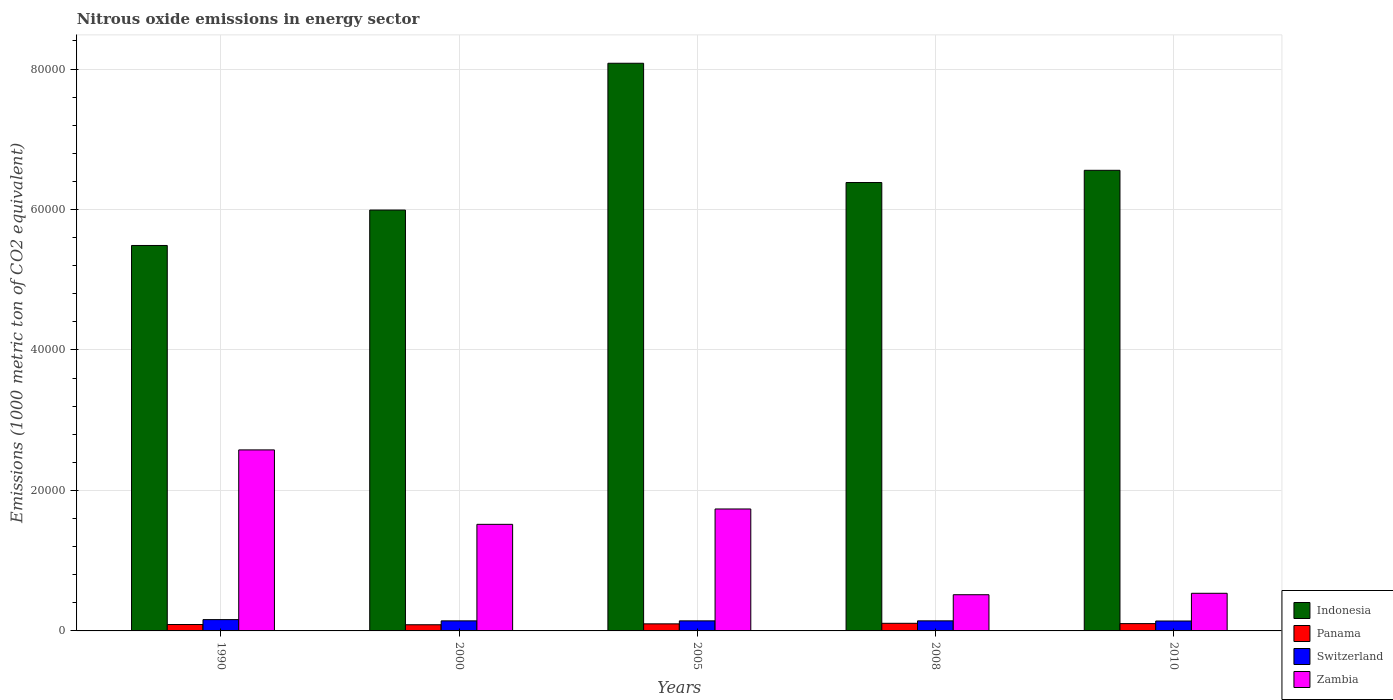Are the number of bars on each tick of the X-axis equal?
Your answer should be very brief. Yes. How many bars are there on the 5th tick from the right?
Your answer should be compact. 4. What is the label of the 3rd group of bars from the left?
Offer a terse response. 2005. In how many cases, is the number of bars for a given year not equal to the number of legend labels?
Give a very brief answer. 0. What is the amount of nitrous oxide emitted in Zambia in 2005?
Ensure brevity in your answer.  1.74e+04. Across all years, what is the maximum amount of nitrous oxide emitted in Panama?
Your answer should be compact. 1084.9. Across all years, what is the minimum amount of nitrous oxide emitted in Panama?
Offer a terse response. 878.4. In which year was the amount of nitrous oxide emitted in Zambia maximum?
Offer a very short reply. 1990. In which year was the amount of nitrous oxide emitted in Zambia minimum?
Make the answer very short. 2008. What is the total amount of nitrous oxide emitted in Indonesia in the graph?
Provide a succinct answer. 3.25e+05. What is the difference between the amount of nitrous oxide emitted in Panama in 1990 and that in 2008?
Ensure brevity in your answer.  -174.5. What is the difference between the amount of nitrous oxide emitted in Switzerland in 2000 and the amount of nitrous oxide emitted in Indonesia in 1990?
Keep it short and to the point. -5.34e+04. What is the average amount of nitrous oxide emitted in Indonesia per year?
Provide a short and direct response. 6.50e+04. In the year 2005, what is the difference between the amount of nitrous oxide emitted in Switzerland and amount of nitrous oxide emitted in Zambia?
Ensure brevity in your answer.  -1.59e+04. What is the ratio of the amount of nitrous oxide emitted in Indonesia in 1990 to that in 2000?
Make the answer very short. 0.92. Is the amount of nitrous oxide emitted in Indonesia in 1990 less than that in 2008?
Your response must be concise. Yes. Is the difference between the amount of nitrous oxide emitted in Switzerland in 2005 and 2010 greater than the difference between the amount of nitrous oxide emitted in Zambia in 2005 and 2010?
Your answer should be compact. No. What is the difference between the highest and the second highest amount of nitrous oxide emitted in Zambia?
Your answer should be compact. 8411.4. What is the difference between the highest and the lowest amount of nitrous oxide emitted in Indonesia?
Give a very brief answer. 2.59e+04. Is the sum of the amount of nitrous oxide emitted in Zambia in 2008 and 2010 greater than the maximum amount of nitrous oxide emitted in Panama across all years?
Your answer should be very brief. Yes. What does the 1st bar from the left in 2005 represents?
Your response must be concise. Indonesia. Are all the bars in the graph horizontal?
Your response must be concise. No. What is the difference between two consecutive major ticks on the Y-axis?
Ensure brevity in your answer.  2.00e+04. Are the values on the major ticks of Y-axis written in scientific E-notation?
Give a very brief answer. No. Does the graph contain any zero values?
Provide a short and direct response. No. Does the graph contain grids?
Offer a terse response. Yes. Where does the legend appear in the graph?
Give a very brief answer. Bottom right. How are the legend labels stacked?
Your answer should be compact. Vertical. What is the title of the graph?
Your response must be concise. Nitrous oxide emissions in energy sector. Does "Samoa" appear as one of the legend labels in the graph?
Provide a short and direct response. No. What is the label or title of the Y-axis?
Provide a succinct answer. Emissions (1000 metric ton of CO2 equivalent). What is the Emissions (1000 metric ton of CO2 equivalent) in Indonesia in 1990?
Offer a terse response. 5.49e+04. What is the Emissions (1000 metric ton of CO2 equivalent) in Panama in 1990?
Your answer should be very brief. 910.4. What is the Emissions (1000 metric ton of CO2 equivalent) in Switzerland in 1990?
Give a very brief answer. 1610.2. What is the Emissions (1000 metric ton of CO2 equivalent) of Zambia in 1990?
Keep it short and to the point. 2.58e+04. What is the Emissions (1000 metric ton of CO2 equivalent) in Indonesia in 2000?
Keep it short and to the point. 5.99e+04. What is the Emissions (1000 metric ton of CO2 equivalent) of Panama in 2000?
Provide a succinct answer. 878.4. What is the Emissions (1000 metric ton of CO2 equivalent) of Switzerland in 2000?
Offer a very short reply. 1432.5. What is the Emissions (1000 metric ton of CO2 equivalent) in Zambia in 2000?
Make the answer very short. 1.52e+04. What is the Emissions (1000 metric ton of CO2 equivalent) of Indonesia in 2005?
Your answer should be compact. 8.08e+04. What is the Emissions (1000 metric ton of CO2 equivalent) in Panama in 2005?
Provide a short and direct response. 1006.8. What is the Emissions (1000 metric ton of CO2 equivalent) in Switzerland in 2005?
Ensure brevity in your answer.  1431.1. What is the Emissions (1000 metric ton of CO2 equivalent) of Zambia in 2005?
Your answer should be compact. 1.74e+04. What is the Emissions (1000 metric ton of CO2 equivalent) in Indonesia in 2008?
Provide a succinct answer. 6.38e+04. What is the Emissions (1000 metric ton of CO2 equivalent) of Panama in 2008?
Provide a succinct answer. 1084.9. What is the Emissions (1000 metric ton of CO2 equivalent) in Switzerland in 2008?
Your answer should be compact. 1433. What is the Emissions (1000 metric ton of CO2 equivalent) of Zambia in 2008?
Make the answer very short. 5152.9. What is the Emissions (1000 metric ton of CO2 equivalent) in Indonesia in 2010?
Provide a succinct answer. 6.56e+04. What is the Emissions (1000 metric ton of CO2 equivalent) of Panama in 2010?
Offer a very short reply. 1040.4. What is the Emissions (1000 metric ton of CO2 equivalent) in Switzerland in 2010?
Ensure brevity in your answer.  1411.6. What is the Emissions (1000 metric ton of CO2 equivalent) in Zambia in 2010?
Keep it short and to the point. 5357.6. Across all years, what is the maximum Emissions (1000 metric ton of CO2 equivalent) in Indonesia?
Make the answer very short. 8.08e+04. Across all years, what is the maximum Emissions (1000 metric ton of CO2 equivalent) of Panama?
Provide a short and direct response. 1084.9. Across all years, what is the maximum Emissions (1000 metric ton of CO2 equivalent) of Switzerland?
Provide a succinct answer. 1610.2. Across all years, what is the maximum Emissions (1000 metric ton of CO2 equivalent) of Zambia?
Make the answer very short. 2.58e+04. Across all years, what is the minimum Emissions (1000 metric ton of CO2 equivalent) of Indonesia?
Give a very brief answer. 5.49e+04. Across all years, what is the minimum Emissions (1000 metric ton of CO2 equivalent) of Panama?
Offer a very short reply. 878.4. Across all years, what is the minimum Emissions (1000 metric ton of CO2 equivalent) of Switzerland?
Provide a succinct answer. 1411.6. Across all years, what is the minimum Emissions (1000 metric ton of CO2 equivalent) of Zambia?
Give a very brief answer. 5152.9. What is the total Emissions (1000 metric ton of CO2 equivalent) of Indonesia in the graph?
Your answer should be very brief. 3.25e+05. What is the total Emissions (1000 metric ton of CO2 equivalent) in Panama in the graph?
Your response must be concise. 4920.9. What is the total Emissions (1000 metric ton of CO2 equivalent) of Switzerland in the graph?
Give a very brief answer. 7318.4. What is the total Emissions (1000 metric ton of CO2 equivalent) of Zambia in the graph?
Make the answer very short. 6.88e+04. What is the difference between the Emissions (1000 metric ton of CO2 equivalent) of Indonesia in 1990 and that in 2000?
Offer a terse response. -5044.7. What is the difference between the Emissions (1000 metric ton of CO2 equivalent) of Panama in 1990 and that in 2000?
Keep it short and to the point. 32. What is the difference between the Emissions (1000 metric ton of CO2 equivalent) of Switzerland in 1990 and that in 2000?
Provide a succinct answer. 177.7. What is the difference between the Emissions (1000 metric ton of CO2 equivalent) in Zambia in 1990 and that in 2000?
Give a very brief answer. 1.06e+04. What is the difference between the Emissions (1000 metric ton of CO2 equivalent) of Indonesia in 1990 and that in 2005?
Ensure brevity in your answer.  -2.59e+04. What is the difference between the Emissions (1000 metric ton of CO2 equivalent) of Panama in 1990 and that in 2005?
Provide a short and direct response. -96.4. What is the difference between the Emissions (1000 metric ton of CO2 equivalent) in Switzerland in 1990 and that in 2005?
Offer a very short reply. 179.1. What is the difference between the Emissions (1000 metric ton of CO2 equivalent) of Zambia in 1990 and that in 2005?
Your answer should be very brief. 8411.4. What is the difference between the Emissions (1000 metric ton of CO2 equivalent) of Indonesia in 1990 and that in 2008?
Provide a succinct answer. -8962.8. What is the difference between the Emissions (1000 metric ton of CO2 equivalent) of Panama in 1990 and that in 2008?
Offer a terse response. -174.5. What is the difference between the Emissions (1000 metric ton of CO2 equivalent) in Switzerland in 1990 and that in 2008?
Ensure brevity in your answer.  177.2. What is the difference between the Emissions (1000 metric ton of CO2 equivalent) in Zambia in 1990 and that in 2008?
Your response must be concise. 2.06e+04. What is the difference between the Emissions (1000 metric ton of CO2 equivalent) in Indonesia in 1990 and that in 2010?
Your answer should be compact. -1.07e+04. What is the difference between the Emissions (1000 metric ton of CO2 equivalent) in Panama in 1990 and that in 2010?
Provide a short and direct response. -130. What is the difference between the Emissions (1000 metric ton of CO2 equivalent) in Switzerland in 1990 and that in 2010?
Give a very brief answer. 198.6. What is the difference between the Emissions (1000 metric ton of CO2 equivalent) in Zambia in 1990 and that in 2010?
Provide a succinct answer. 2.04e+04. What is the difference between the Emissions (1000 metric ton of CO2 equivalent) in Indonesia in 2000 and that in 2005?
Your answer should be very brief. -2.09e+04. What is the difference between the Emissions (1000 metric ton of CO2 equivalent) in Panama in 2000 and that in 2005?
Make the answer very short. -128.4. What is the difference between the Emissions (1000 metric ton of CO2 equivalent) of Zambia in 2000 and that in 2005?
Provide a short and direct response. -2187.2. What is the difference between the Emissions (1000 metric ton of CO2 equivalent) of Indonesia in 2000 and that in 2008?
Your answer should be compact. -3918.1. What is the difference between the Emissions (1000 metric ton of CO2 equivalent) in Panama in 2000 and that in 2008?
Offer a very short reply. -206.5. What is the difference between the Emissions (1000 metric ton of CO2 equivalent) in Zambia in 2000 and that in 2008?
Your answer should be very brief. 1.00e+04. What is the difference between the Emissions (1000 metric ton of CO2 equivalent) in Indonesia in 2000 and that in 2010?
Give a very brief answer. -5659.3. What is the difference between the Emissions (1000 metric ton of CO2 equivalent) in Panama in 2000 and that in 2010?
Your response must be concise. -162. What is the difference between the Emissions (1000 metric ton of CO2 equivalent) of Switzerland in 2000 and that in 2010?
Your response must be concise. 20.9. What is the difference between the Emissions (1000 metric ton of CO2 equivalent) in Zambia in 2000 and that in 2010?
Make the answer very short. 9818.5. What is the difference between the Emissions (1000 metric ton of CO2 equivalent) of Indonesia in 2005 and that in 2008?
Ensure brevity in your answer.  1.70e+04. What is the difference between the Emissions (1000 metric ton of CO2 equivalent) in Panama in 2005 and that in 2008?
Provide a succinct answer. -78.1. What is the difference between the Emissions (1000 metric ton of CO2 equivalent) of Zambia in 2005 and that in 2008?
Offer a very short reply. 1.22e+04. What is the difference between the Emissions (1000 metric ton of CO2 equivalent) of Indonesia in 2005 and that in 2010?
Offer a very short reply. 1.52e+04. What is the difference between the Emissions (1000 metric ton of CO2 equivalent) in Panama in 2005 and that in 2010?
Provide a succinct answer. -33.6. What is the difference between the Emissions (1000 metric ton of CO2 equivalent) of Zambia in 2005 and that in 2010?
Offer a very short reply. 1.20e+04. What is the difference between the Emissions (1000 metric ton of CO2 equivalent) in Indonesia in 2008 and that in 2010?
Offer a terse response. -1741.2. What is the difference between the Emissions (1000 metric ton of CO2 equivalent) in Panama in 2008 and that in 2010?
Offer a terse response. 44.5. What is the difference between the Emissions (1000 metric ton of CO2 equivalent) in Switzerland in 2008 and that in 2010?
Give a very brief answer. 21.4. What is the difference between the Emissions (1000 metric ton of CO2 equivalent) of Zambia in 2008 and that in 2010?
Your response must be concise. -204.7. What is the difference between the Emissions (1000 metric ton of CO2 equivalent) of Indonesia in 1990 and the Emissions (1000 metric ton of CO2 equivalent) of Panama in 2000?
Ensure brevity in your answer.  5.40e+04. What is the difference between the Emissions (1000 metric ton of CO2 equivalent) of Indonesia in 1990 and the Emissions (1000 metric ton of CO2 equivalent) of Switzerland in 2000?
Ensure brevity in your answer.  5.34e+04. What is the difference between the Emissions (1000 metric ton of CO2 equivalent) of Indonesia in 1990 and the Emissions (1000 metric ton of CO2 equivalent) of Zambia in 2000?
Your answer should be compact. 3.97e+04. What is the difference between the Emissions (1000 metric ton of CO2 equivalent) of Panama in 1990 and the Emissions (1000 metric ton of CO2 equivalent) of Switzerland in 2000?
Your response must be concise. -522.1. What is the difference between the Emissions (1000 metric ton of CO2 equivalent) of Panama in 1990 and the Emissions (1000 metric ton of CO2 equivalent) of Zambia in 2000?
Offer a terse response. -1.43e+04. What is the difference between the Emissions (1000 metric ton of CO2 equivalent) in Switzerland in 1990 and the Emissions (1000 metric ton of CO2 equivalent) in Zambia in 2000?
Your answer should be very brief. -1.36e+04. What is the difference between the Emissions (1000 metric ton of CO2 equivalent) in Indonesia in 1990 and the Emissions (1000 metric ton of CO2 equivalent) in Panama in 2005?
Keep it short and to the point. 5.39e+04. What is the difference between the Emissions (1000 metric ton of CO2 equivalent) in Indonesia in 1990 and the Emissions (1000 metric ton of CO2 equivalent) in Switzerland in 2005?
Ensure brevity in your answer.  5.35e+04. What is the difference between the Emissions (1000 metric ton of CO2 equivalent) of Indonesia in 1990 and the Emissions (1000 metric ton of CO2 equivalent) of Zambia in 2005?
Your answer should be very brief. 3.75e+04. What is the difference between the Emissions (1000 metric ton of CO2 equivalent) in Panama in 1990 and the Emissions (1000 metric ton of CO2 equivalent) in Switzerland in 2005?
Provide a succinct answer. -520.7. What is the difference between the Emissions (1000 metric ton of CO2 equivalent) of Panama in 1990 and the Emissions (1000 metric ton of CO2 equivalent) of Zambia in 2005?
Give a very brief answer. -1.65e+04. What is the difference between the Emissions (1000 metric ton of CO2 equivalent) in Switzerland in 1990 and the Emissions (1000 metric ton of CO2 equivalent) in Zambia in 2005?
Your response must be concise. -1.58e+04. What is the difference between the Emissions (1000 metric ton of CO2 equivalent) of Indonesia in 1990 and the Emissions (1000 metric ton of CO2 equivalent) of Panama in 2008?
Give a very brief answer. 5.38e+04. What is the difference between the Emissions (1000 metric ton of CO2 equivalent) in Indonesia in 1990 and the Emissions (1000 metric ton of CO2 equivalent) in Switzerland in 2008?
Ensure brevity in your answer.  5.34e+04. What is the difference between the Emissions (1000 metric ton of CO2 equivalent) in Indonesia in 1990 and the Emissions (1000 metric ton of CO2 equivalent) in Zambia in 2008?
Offer a terse response. 4.97e+04. What is the difference between the Emissions (1000 metric ton of CO2 equivalent) of Panama in 1990 and the Emissions (1000 metric ton of CO2 equivalent) of Switzerland in 2008?
Provide a short and direct response. -522.6. What is the difference between the Emissions (1000 metric ton of CO2 equivalent) in Panama in 1990 and the Emissions (1000 metric ton of CO2 equivalent) in Zambia in 2008?
Make the answer very short. -4242.5. What is the difference between the Emissions (1000 metric ton of CO2 equivalent) in Switzerland in 1990 and the Emissions (1000 metric ton of CO2 equivalent) in Zambia in 2008?
Offer a very short reply. -3542.7. What is the difference between the Emissions (1000 metric ton of CO2 equivalent) in Indonesia in 1990 and the Emissions (1000 metric ton of CO2 equivalent) in Panama in 2010?
Keep it short and to the point. 5.38e+04. What is the difference between the Emissions (1000 metric ton of CO2 equivalent) in Indonesia in 1990 and the Emissions (1000 metric ton of CO2 equivalent) in Switzerland in 2010?
Ensure brevity in your answer.  5.35e+04. What is the difference between the Emissions (1000 metric ton of CO2 equivalent) of Indonesia in 1990 and the Emissions (1000 metric ton of CO2 equivalent) of Zambia in 2010?
Offer a very short reply. 4.95e+04. What is the difference between the Emissions (1000 metric ton of CO2 equivalent) of Panama in 1990 and the Emissions (1000 metric ton of CO2 equivalent) of Switzerland in 2010?
Your answer should be compact. -501.2. What is the difference between the Emissions (1000 metric ton of CO2 equivalent) of Panama in 1990 and the Emissions (1000 metric ton of CO2 equivalent) of Zambia in 2010?
Offer a very short reply. -4447.2. What is the difference between the Emissions (1000 metric ton of CO2 equivalent) in Switzerland in 1990 and the Emissions (1000 metric ton of CO2 equivalent) in Zambia in 2010?
Your response must be concise. -3747.4. What is the difference between the Emissions (1000 metric ton of CO2 equivalent) of Indonesia in 2000 and the Emissions (1000 metric ton of CO2 equivalent) of Panama in 2005?
Ensure brevity in your answer.  5.89e+04. What is the difference between the Emissions (1000 metric ton of CO2 equivalent) of Indonesia in 2000 and the Emissions (1000 metric ton of CO2 equivalent) of Switzerland in 2005?
Give a very brief answer. 5.85e+04. What is the difference between the Emissions (1000 metric ton of CO2 equivalent) of Indonesia in 2000 and the Emissions (1000 metric ton of CO2 equivalent) of Zambia in 2005?
Your response must be concise. 4.26e+04. What is the difference between the Emissions (1000 metric ton of CO2 equivalent) in Panama in 2000 and the Emissions (1000 metric ton of CO2 equivalent) in Switzerland in 2005?
Offer a terse response. -552.7. What is the difference between the Emissions (1000 metric ton of CO2 equivalent) of Panama in 2000 and the Emissions (1000 metric ton of CO2 equivalent) of Zambia in 2005?
Your answer should be compact. -1.65e+04. What is the difference between the Emissions (1000 metric ton of CO2 equivalent) of Switzerland in 2000 and the Emissions (1000 metric ton of CO2 equivalent) of Zambia in 2005?
Provide a short and direct response. -1.59e+04. What is the difference between the Emissions (1000 metric ton of CO2 equivalent) in Indonesia in 2000 and the Emissions (1000 metric ton of CO2 equivalent) in Panama in 2008?
Keep it short and to the point. 5.88e+04. What is the difference between the Emissions (1000 metric ton of CO2 equivalent) in Indonesia in 2000 and the Emissions (1000 metric ton of CO2 equivalent) in Switzerland in 2008?
Keep it short and to the point. 5.85e+04. What is the difference between the Emissions (1000 metric ton of CO2 equivalent) in Indonesia in 2000 and the Emissions (1000 metric ton of CO2 equivalent) in Zambia in 2008?
Offer a very short reply. 5.48e+04. What is the difference between the Emissions (1000 metric ton of CO2 equivalent) in Panama in 2000 and the Emissions (1000 metric ton of CO2 equivalent) in Switzerland in 2008?
Ensure brevity in your answer.  -554.6. What is the difference between the Emissions (1000 metric ton of CO2 equivalent) of Panama in 2000 and the Emissions (1000 metric ton of CO2 equivalent) of Zambia in 2008?
Your answer should be compact. -4274.5. What is the difference between the Emissions (1000 metric ton of CO2 equivalent) in Switzerland in 2000 and the Emissions (1000 metric ton of CO2 equivalent) in Zambia in 2008?
Your answer should be very brief. -3720.4. What is the difference between the Emissions (1000 metric ton of CO2 equivalent) in Indonesia in 2000 and the Emissions (1000 metric ton of CO2 equivalent) in Panama in 2010?
Offer a very short reply. 5.89e+04. What is the difference between the Emissions (1000 metric ton of CO2 equivalent) of Indonesia in 2000 and the Emissions (1000 metric ton of CO2 equivalent) of Switzerland in 2010?
Your response must be concise. 5.85e+04. What is the difference between the Emissions (1000 metric ton of CO2 equivalent) of Indonesia in 2000 and the Emissions (1000 metric ton of CO2 equivalent) of Zambia in 2010?
Offer a terse response. 5.46e+04. What is the difference between the Emissions (1000 metric ton of CO2 equivalent) in Panama in 2000 and the Emissions (1000 metric ton of CO2 equivalent) in Switzerland in 2010?
Your response must be concise. -533.2. What is the difference between the Emissions (1000 metric ton of CO2 equivalent) of Panama in 2000 and the Emissions (1000 metric ton of CO2 equivalent) of Zambia in 2010?
Keep it short and to the point. -4479.2. What is the difference between the Emissions (1000 metric ton of CO2 equivalent) in Switzerland in 2000 and the Emissions (1000 metric ton of CO2 equivalent) in Zambia in 2010?
Keep it short and to the point. -3925.1. What is the difference between the Emissions (1000 metric ton of CO2 equivalent) of Indonesia in 2005 and the Emissions (1000 metric ton of CO2 equivalent) of Panama in 2008?
Provide a short and direct response. 7.97e+04. What is the difference between the Emissions (1000 metric ton of CO2 equivalent) in Indonesia in 2005 and the Emissions (1000 metric ton of CO2 equivalent) in Switzerland in 2008?
Your answer should be compact. 7.94e+04. What is the difference between the Emissions (1000 metric ton of CO2 equivalent) in Indonesia in 2005 and the Emissions (1000 metric ton of CO2 equivalent) in Zambia in 2008?
Provide a short and direct response. 7.57e+04. What is the difference between the Emissions (1000 metric ton of CO2 equivalent) in Panama in 2005 and the Emissions (1000 metric ton of CO2 equivalent) in Switzerland in 2008?
Make the answer very short. -426.2. What is the difference between the Emissions (1000 metric ton of CO2 equivalent) in Panama in 2005 and the Emissions (1000 metric ton of CO2 equivalent) in Zambia in 2008?
Make the answer very short. -4146.1. What is the difference between the Emissions (1000 metric ton of CO2 equivalent) in Switzerland in 2005 and the Emissions (1000 metric ton of CO2 equivalent) in Zambia in 2008?
Give a very brief answer. -3721.8. What is the difference between the Emissions (1000 metric ton of CO2 equivalent) of Indonesia in 2005 and the Emissions (1000 metric ton of CO2 equivalent) of Panama in 2010?
Your answer should be very brief. 7.98e+04. What is the difference between the Emissions (1000 metric ton of CO2 equivalent) of Indonesia in 2005 and the Emissions (1000 metric ton of CO2 equivalent) of Switzerland in 2010?
Provide a succinct answer. 7.94e+04. What is the difference between the Emissions (1000 metric ton of CO2 equivalent) in Indonesia in 2005 and the Emissions (1000 metric ton of CO2 equivalent) in Zambia in 2010?
Your answer should be compact. 7.55e+04. What is the difference between the Emissions (1000 metric ton of CO2 equivalent) of Panama in 2005 and the Emissions (1000 metric ton of CO2 equivalent) of Switzerland in 2010?
Provide a short and direct response. -404.8. What is the difference between the Emissions (1000 metric ton of CO2 equivalent) of Panama in 2005 and the Emissions (1000 metric ton of CO2 equivalent) of Zambia in 2010?
Your answer should be very brief. -4350.8. What is the difference between the Emissions (1000 metric ton of CO2 equivalent) in Switzerland in 2005 and the Emissions (1000 metric ton of CO2 equivalent) in Zambia in 2010?
Your answer should be very brief. -3926.5. What is the difference between the Emissions (1000 metric ton of CO2 equivalent) in Indonesia in 2008 and the Emissions (1000 metric ton of CO2 equivalent) in Panama in 2010?
Your answer should be very brief. 6.28e+04. What is the difference between the Emissions (1000 metric ton of CO2 equivalent) of Indonesia in 2008 and the Emissions (1000 metric ton of CO2 equivalent) of Switzerland in 2010?
Make the answer very short. 6.24e+04. What is the difference between the Emissions (1000 metric ton of CO2 equivalent) in Indonesia in 2008 and the Emissions (1000 metric ton of CO2 equivalent) in Zambia in 2010?
Offer a very short reply. 5.85e+04. What is the difference between the Emissions (1000 metric ton of CO2 equivalent) in Panama in 2008 and the Emissions (1000 metric ton of CO2 equivalent) in Switzerland in 2010?
Offer a very short reply. -326.7. What is the difference between the Emissions (1000 metric ton of CO2 equivalent) of Panama in 2008 and the Emissions (1000 metric ton of CO2 equivalent) of Zambia in 2010?
Offer a very short reply. -4272.7. What is the difference between the Emissions (1000 metric ton of CO2 equivalent) of Switzerland in 2008 and the Emissions (1000 metric ton of CO2 equivalent) of Zambia in 2010?
Your answer should be compact. -3924.6. What is the average Emissions (1000 metric ton of CO2 equivalent) in Indonesia per year?
Give a very brief answer. 6.50e+04. What is the average Emissions (1000 metric ton of CO2 equivalent) of Panama per year?
Make the answer very short. 984.18. What is the average Emissions (1000 metric ton of CO2 equivalent) of Switzerland per year?
Offer a very short reply. 1463.68. What is the average Emissions (1000 metric ton of CO2 equivalent) of Zambia per year?
Your response must be concise. 1.38e+04. In the year 1990, what is the difference between the Emissions (1000 metric ton of CO2 equivalent) of Indonesia and Emissions (1000 metric ton of CO2 equivalent) of Panama?
Keep it short and to the point. 5.40e+04. In the year 1990, what is the difference between the Emissions (1000 metric ton of CO2 equivalent) of Indonesia and Emissions (1000 metric ton of CO2 equivalent) of Switzerland?
Provide a short and direct response. 5.33e+04. In the year 1990, what is the difference between the Emissions (1000 metric ton of CO2 equivalent) of Indonesia and Emissions (1000 metric ton of CO2 equivalent) of Zambia?
Your answer should be very brief. 2.91e+04. In the year 1990, what is the difference between the Emissions (1000 metric ton of CO2 equivalent) of Panama and Emissions (1000 metric ton of CO2 equivalent) of Switzerland?
Offer a very short reply. -699.8. In the year 1990, what is the difference between the Emissions (1000 metric ton of CO2 equivalent) in Panama and Emissions (1000 metric ton of CO2 equivalent) in Zambia?
Give a very brief answer. -2.49e+04. In the year 1990, what is the difference between the Emissions (1000 metric ton of CO2 equivalent) of Switzerland and Emissions (1000 metric ton of CO2 equivalent) of Zambia?
Offer a very short reply. -2.42e+04. In the year 2000, what is the difference between the Emissions (1000 metric ton of CO2 equivalent) of Indonesia and Emissions (1000 metric ton of CO2 equivalent) of Panama?
Keep it short and to the point. 5.90e+04. In the year 2000, what is the difference between the Emissions (1000 metric ton of CO2 equivalent) of Indonesia and Emissions (1000 metric ton of CO2 equivalent) of Switzerland?
Ensure brevity in your answer.  5.85e+04. In the year 2000, what is the difference between the Emissions (1000 metric ton of CO2 equivalent) of Indonesia and Emissions (1000 metric ton of CO2 equivalent) of Zambia?
Your response must be concise. 4.47e+04. In the year 2000, what is the difference between the Emissions (1000 metric ton of CO2 equivalent) of Panama and Emissions (1000 metric ton of CO2 equivalent) of Switzerland?
Your answer should be compact. -554.1. In the year 2000, what is the difference between the Emissions (1000 metric ton of CO2 equivalent) of Panama and Emissions (1000 metric ton of CO2 equivalent) of Zambia?
Give a very brief answer. -1.43e+04. In the year 2000, what is the difference between the Emissions (1000 metric ton of CO2 equivalent) of Switzerland and Emissions (1000 metric ton of CO2 equivalent) of Zambia?
Give a very brief answer. -1.37e+04. In the year 2005, what is the difference between the Emissions (1000 metric ton of CO2 equivalent) of Indonesia and Emissions (1000 metric ton of CO2 equivalent) of Panama?
Offer a terse response. 7.98e+04. In the year 2005, what is the difference between the Emissions (1000 metric ton of CO2 equivalent) of Indonesia and Emissions (1000 metric ton of CO2 equivalent) of Switzerland?
Make the answer very short. 7.94e+04. In the year 2005, what is the difference between the Emissions (1000 metric ton of CO2 equivalent) in Indonesia and Emissions (1000 metric ton of CO2 equivalent) in Zambia?
Make the answer very short. 6.35e+04. In the year 2005, what is the difference between the Emissions (1000 metric ton of CO2 equivalent) in Panama and Emissions (1000 metric ton of CO2 equivalent) in Switzerland?
Provide a short and direct response. -424.3. In the year 2005, what is the difference between the Emissions (1000 metric ton of CO2 equivalent) in Panama and Emissions (1000 metric ton of CO2 equivalent) in Zambia?
Your response must be concise. -1.64e+04. In the year 2005, what is the difference between the Emissions (1000 metric ton of CO2 equivalent) of Switzerland and Emissions (1000 metric ton of CO2 equivalent) of Zambia?
Provide a succinct answer. -1.59e+04. In the year 2008, what is the difference between the Emissions (1000 metric ton of CO2 equivalent) of Indonesia and Emissions (1000 metric ton of CO2 equivalent) of Panama?
Provide a succinct answer. 6.28e+04. In the year 2008, what is the difference between the Emissions (1000 metric ton of CO2 equivalent) of Indonesia and Emissions (1000 metric ton of CO2 equivalent) of Switzerland?
Your answer should be very brief. 6.24e+04. In the year 2008, what is the difference between the Emissions (1000 metric ton of CO2 equivalent) of Indonesia and Emissions (1000 metric ton of CO2 equivalent) of Zambia?
Your response must be concise. 5.87e+04. In the year 2008, what is the difference between the Emissions (1000 metric ton of CO2 equivalent) of Panama and Emissions (1000 metric ton of CO2 equivalent) of Switzerland?
Your answer should be very brief. -348.1. In the year 2008, what is the difference between the Emissions (1000 metric ton of CO2 equivalent) of Panama and Emissions (1000 metric ton of CO2 equivalent) of Zambia?
Make the answer very short. -4068. In the year 2008, what is the difference between the Emissions (1000 metric ton of CO2 equivalent) in Switzerland and Emissions (1000 metric ton of CO2 equivalent) in Zambia?
Ensure brevity in your answer.  -3719.9. In the year 2010, what is the difference between the Emissions (1000 metric ton of CO2 equivalent) of Indonesia and Emissions (1000 metric ton of CO2 equivalent) of Panama?
Your answer should be compact. 6.45e+04. In the year 2010, what is the difference between the Emissions (1000 metric ton of CO2 equivalent) of Indonesia and Emissions (1000 metric ton of CO2 equivalent) of Switzerland?
Give a very brief answer. 6.42e+04. In the year 2010, what is the difference between the Emissions (1000 metric ton of CO2 equivalent) in Indonesia and Emissions (1000 metric ton of CO2 equivalent) in Zambia?
Your answer should be very brief. 6.02e+04. In the year 2010, what is the difference between the Emissions (1000 metric ton of CO2 equivalent) in Panama and Emissions (1000 metric ton of CO2 equivalent) in Switzerland?
Make the answer very short. -371.2. In the year 2010, what is the difference between the Emissions (1000 metric ton of CO2 equivalent) of Panama and Emissions (1000 metric ton of CO2 equivalent) of Zambia?
Your answer should be compact. -4317.2. In the year 2010, what is the difference between the Emissions (1000 metric ton of CO2 equivalent) in Switzerland and Emissions (1000 metric ton of CO2 equivalent) in Zambia?
Your answer should be compact. -3946. What is the ratio of the Emissions (1000 metric ton of CO2 equivalent) of Indonesia in 1990 to that in 2000?
Keep it short and to the point. 0.92. What is the ratio of the Emissions (1000 metric ton of CO2 equivalent) in Panama in 1990 to that in 2000?
Offer a very short reply. 1.04. What is the ratio of the Emissions (1000 metric ton of CO2 equivalent) of Switzerland in 1990 to that in 2000?
Your answer should be compact. 1.12. What is the ratio of the Emissions (1000 metric ton of CO2 equivalent) in Zambia in 1990 to that in 2000?
Provide a short and direct response. 1.7. What is the ratio of the Emissions (1000 metric ton of CO2 equivalent) of Indonesia in 1990 to that in 2005?
Your response must be concise. 0.68. What is the ratio of the Emissions (1000 metric ton of CO2 equivalent) of Panama in 1990 to that in 2005?
Your response must be concise. 0.9. What is the ratio of the Emissions (1000 metric ton of CO2 equivalent) in Switzerland in 1990 to that in 2005?
Offer a very short reply. 1.13. What is the ratio of the Emissions (1000 metric ton of CO2 equivalent) in Zambia in 1990 to that in 2005?
Make the answer very short. 1.48. What is the ratio of the Emissions (1000 metric ton of CO2 equivalent) of Indonesia in 1990 to that in 2008?
Provide a short and direct response. 0.86. What is the ratio of the Emissions (1000 metric ton of CO2 equivalent) of Panama in 1990 to that in 2008?
Give a very brief answer. 0.84. What is the ratio of the Emissions (1000 metric ton of CO2 equivalent) of Switzerland in 1990 to that in 2008?
Offer a terse response. 1.12. What is the ratio of the Emissions (1000 metric ton of CO2 equivalent) of Zambia in 1990 to that in 2008?
Provide a succinct answer. 5. What is the ratio of the Emissions (1000 metric ton of CO2 equivalent) in Indonesia in 1990 to that in 2010?
Give a very brief answer. 0.84. What is the ratio of the Emissions (1000 metric ton of CO2 equivalent) in Panama in 1990 to that in 2010?
Provide a short and direct response. 0.88. What is the ratio of the Emissions (1000 metric ton of CO2 equivalent) of Switzerland in 1990 to that in 2010?
Your response must be concise. 1.14. What is the ratio of the Emissions (1000 metric ton of CO2 equivalent) in Zambia in 1990 to that in 2010?
Provide a succinct answer. 4.81. What is the ratio of the Emissions (1000 metric ton of CO2 equivalent) in Indonesia in 2000 to that in 2005?
Make the answer very short. 0.74. What is the ratio of the Emissions (1000 metric ton of CO2 equivalent) in Panama in 2000 to that in 2005?
Your response must be concise. 0.87. What is the ratio of the Emissions (1000 metric ton of CO2 equivalent) of Switzerland in 2000 to that in 2005?
Make the answer very short. 1. What is the ratio of the Emissions (1000 metric ton of CO2 equivalent) of Zambia in 2000 to that in 2005?
Offer a terse response. 0.87. What is the ratio of the Emissions (1000 metric ton of CO2 equivalent) of Indonesia in 2000 to that in 2008?
Your answer should be compact. 0.94. What is the ratio of the Emissions (1000 metric ton of CO2 equivalent) of Panama in 2000 to that in 2008?
Keep it short and to the point. 0.81. What is the ratio of the Emissions (1000 metric ton of CO2 equivalent) in Zambia in 2000 to that in 2008?
Provide a short and direct response. 2.95. What is the ratio of the Emissions (1000 metric ton of CO2 equivalent) in Indonesia in 2000 to that in 2010?
Provide a short and direct response. 0.91. What is the ratio of the Emissions (1000 metric ton of CO2 equivalent) in Panama in 2000 to that in 2010?
Ensure brevity in your answer.  0.84. What is the ratio of the Emissions (1000 metric ton of CO2 equivalent) in Switzerland in 2000 to that in 2010?
Provide a succinct answer. 1.01. What is the ratio of the Emissions (1000 metric ton of CO2 equivalent) of Zambia in 2000 to that in 2010?
Offer a terse response. 2.83. What is the ratio of the Emissions (1000 metric ton of CO2 equivalent) in Indonesia in 2005 to that in 2008?
Provide a short and direct response. 1.27. What is the ratio of the Emissions (1000 metric ton of CO2 equivalent) in Panama in 2005 to that in 2008?
Your response must be concise. 0.93. What is the ratio of the Emissions (1000 metric ton of CO2 equivalent) in Zambia in 2005 to that in 2008?
Make the answer very short. 3.37. What is the ratio of the Emissions (1000 metric ton of CO2 equivalent) of Indonesia in 2005 to that in 2010?
Make the answer very short. 1.23. What is the ratio of the Emissions (1000 metric ton of CO2 equivalent) in Switzerland in 2005 to that in 2010?
Offer a very short reply. 1.01. What is the ratio of the Emissions (1000 metric ton of CO2 equivalent) of Zambia in 2005 to that in 2010?
Provide a short and direct response. 3.24. What is the ratio of the Emissions (1000 metric ton of CO2 equivalent) of Indonesia in 2008 to that in 2010?
Your answer should be very brief. 0.97. What is the ratio of the Emissions (1000 metric ton of CO2 equivalent) in Panama in 2008 to that in 2010?
Offer a terse response. 1.04. What is the ratio of the Emissions (1000 metric ton of CO2 equivalent) of Switzerland in 2008 to that in 2010?
Your answer should be very brief. 1.02. What is the ratio of the Emissions (1000 metric ton of CO2 equivalent) in Zambia in 2008 to that in 2010?
Your answer should be compact. 0.96. What is the difference between the highest and the second highest Emissions (1000 metric ton of CO2 equivalent) of Indonesia?
Your answer should be very brief. 1.52e+04. What is the difference between the highest and the second highest Emissions (1000 metric ton of CO2 equivalent) in Panama?
Ensure brevity in your answer.  44.5. What is the difference between the highest and the second highest Emissions (1000 metric ton of CO2 equivalent) of Switzerland?
Offer a very short reply. 177.2. What is the difference between the highest and the second highest Emissions (1000 metric ton of CO2 equivalent) in Zambia?
Your answer should be compact. 8411.4. What is the difference between the highest and the lowest Emissions (1000 metric ton of CO2 equivalent) in Indonesia?
Keep it short and to the point. 2.59e+04. What is the difference between the highest and the lowest Emissions (1000 metric ton of CO2 equivalent) of Panama?
Keep it short and to the point. 206.5. What is the difference between the highest and the lowest Emissions (1000 metric ton of CO2 equivalent) in Switzerland?
Provide a short and direct response. 198.6. What is the difference between the highest and the lowest Emissions (1000 metric ton of CO2 equivalent) of Zambia?
Offer a very short reply. 2.06e+04. 